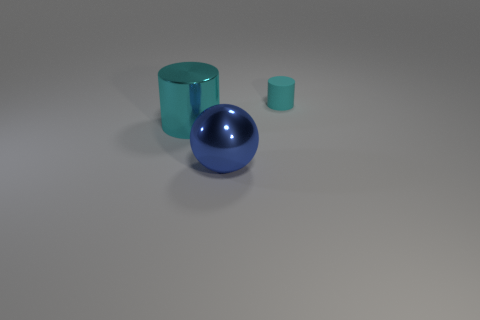Add 1 blue spheres. How many objects exist? 4 Subtract all cylinders. How many objects are left? 1 Add 1 cyan rubber cylinders. How many cyan rubber cylinders are left? 2 Add 3 red matte balls. How many red matte balls exist? 3 Subtract 0 red cylinders. How many objects are left? 3 Subtract all tiny cyan blocks. Subtract all blue spheres. How many objects are left? 2 